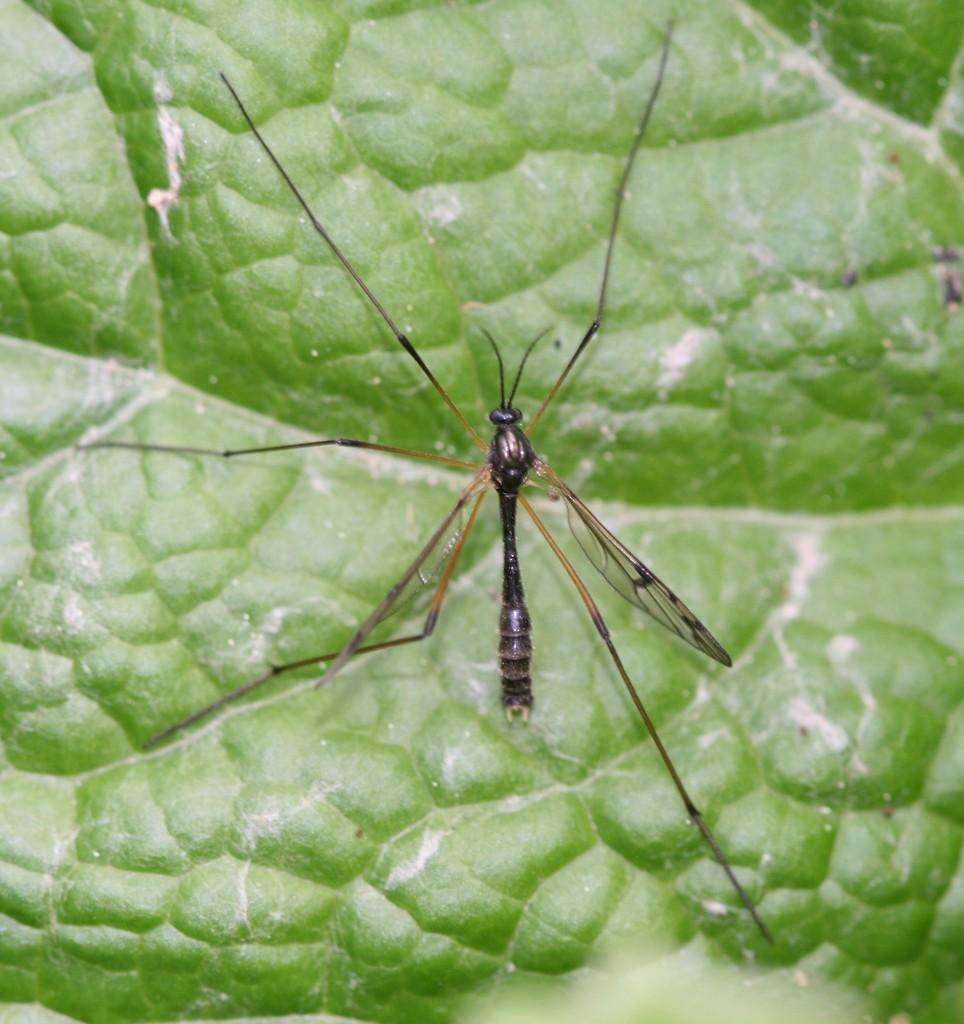What is present in the image? There is an insect in the image. Where is the insect located? The insect is sitting on a leaf. How many voyages has the insect completed in the image? There is no information about voyages in the image, as it only shows an insect sitting on a leaf. 